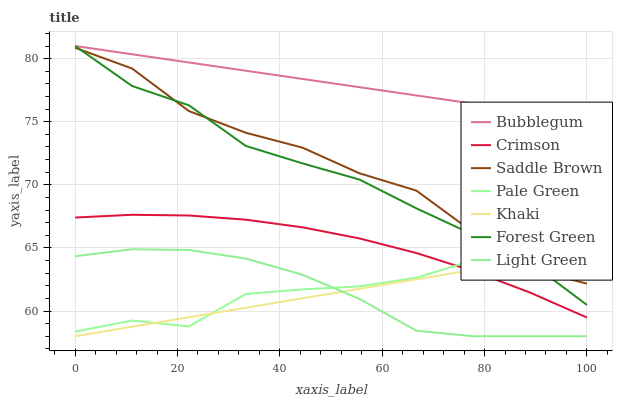Does Khaki have the minimum area under the curve?
Answer yes or no. Yes. Does Bubblegum have the maximum area under the curve?
Answer yes or no. Yes. Does Forest Green have the minimum area under the curve?
Answer yes or no. No. Does Forest Green have the maximum area under the curve?
Answer yes or no. No. Is Bubblegum the smoothest?
Answer yes or no. Yes. Is Pale Green the roughest?
Answer yes or no. Yes. Is Forest Green the smoothest?
Answer yes or no. No. Is Forest Green the roughest?
Answer yes or no. No. Does Forest Green have the lowest value?
Answer yes or no. No. Does Forest Green have the highest value?
Answer yes or no. Yes. Does Pale Green have the highest value?
Answer yes or no. No. Is Khaki less than Bubblegum?
Answer yes or no. Yes. Is Saddle Brown greater than Crimson?
Answer yes or no. Yes. Does Pale Green intersect Forest Green?
Answer yes or no. Yes. Is Pale Green less than Forest Green?
Answer yes or no. No. Is Pale Green greater than Forest Green?
Answer yes or no. No. Does Khaki intersect Bubblegum?
Answer yes or no. No. 